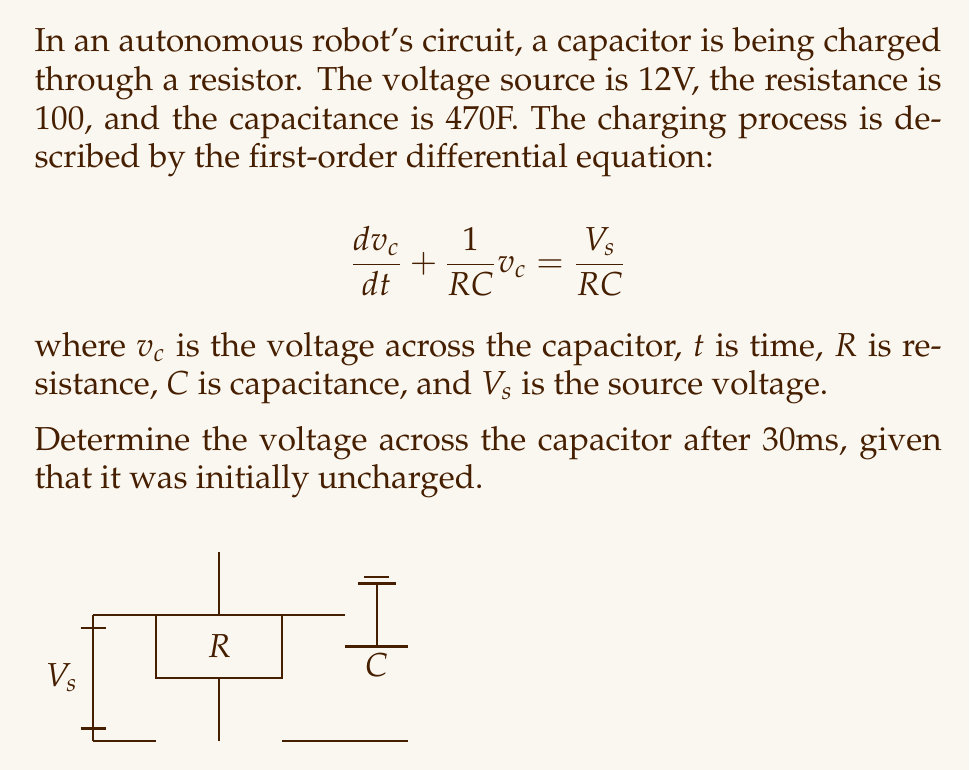Can you answer this question? Let's solve this step-by-step:

1) The general solution for this first-order differential equation is:

   $$v_c(t) = V_s(1 - e^{-t/\tau})$$

   where $\tau = RC$ is the time constant.

2) Calculate the time constant:
   $$\tau = RC = 100\Omega \times 470\mu F = 47 \times 10^{-3}s = 47ms$$

3) Substitute the values into the general solution:
   $$v_c(t) = 12(1 - e^{-t/0.047})$$

4) We need to find $v_c$ at $t = 30ms = 0.03s$:
   $$v_c(0.03) = 12(1 - e^{-0.03/0.047})$$

5) Calculate the exponent:
   $$-0.03/0.047 \approx -0.6383$$

6) Evaluate the exponential:
   $$e^{-0.6383} \approx 0.5282$$

7) Complete the calculation:
   $$v_c(0.03) = 12(1 - 0.5282) \approx 12 \times 0.4718 \approx 5.6616V$$

Therefore, after 30ms, the voltage across the capacitor is approximately 5.66V.
Answer: $5.66V$ 